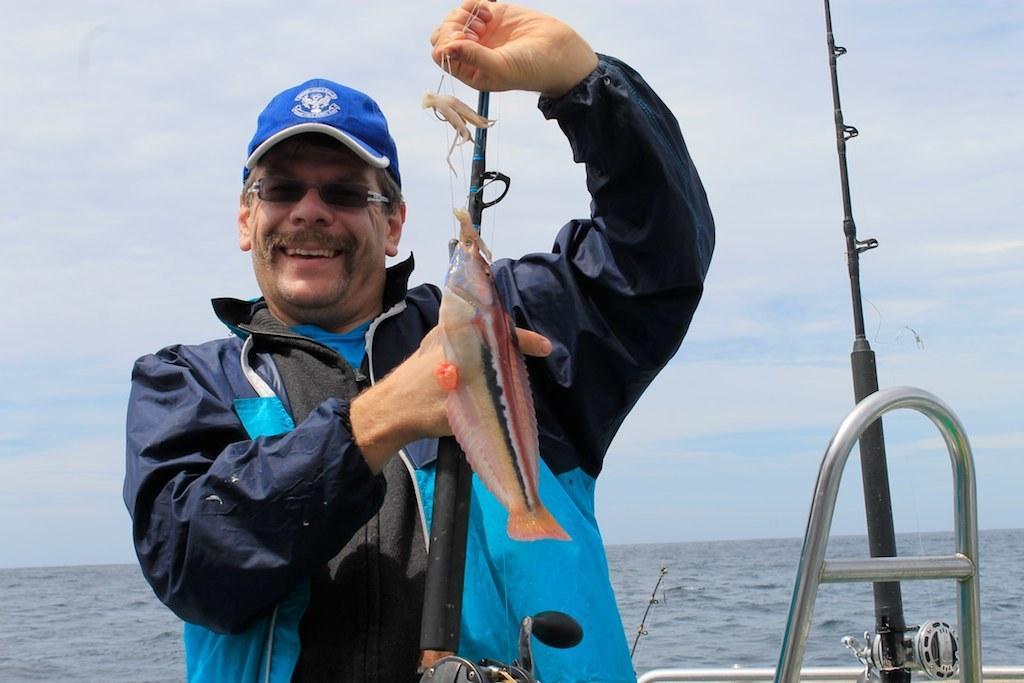Describe this image in one or two sentences. This picture is clicked outside the city. In the foreground there is a man smiling, standing and holding a fish. In the background we can see the sky, water body and some metal rods. 